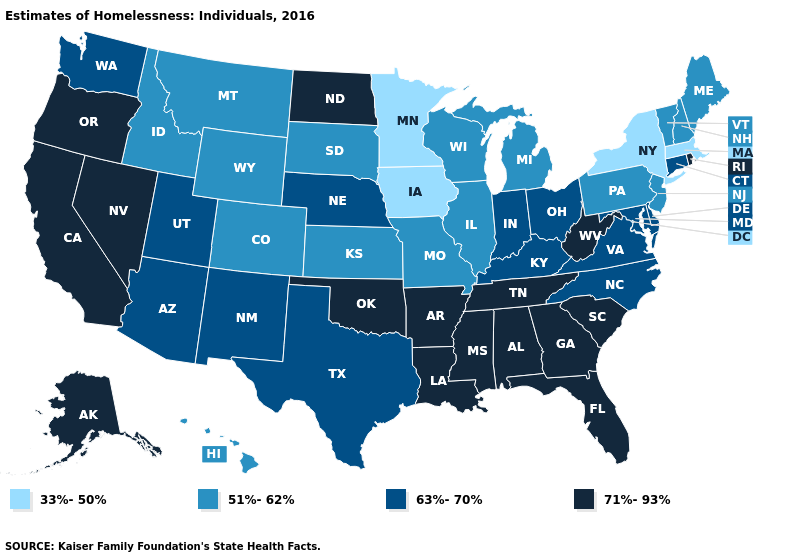Among the states that border Arizona , does Nevada have the highest value?
Give a very brief answer. Yes. Does Colorado have the lowest value in the West?
Answer briefly. Yes. Name the states that have a value in the range 33%-50%?
Be succinct. Iowa, Massachusetts, Minnesota, New York. Does Maine have the lowest value in the Northeast?
Quick response, please. No. What is the highest value in the USA?
Write a very short answer. 71%-93%. What is the lowest value in the Northeast?
Keep it brief. 33%-50%. Among the states that border North Dakota , which have the lowest value?
Short answer required. Minnesota. Name the states that have a value in the range 63%-70%?
Concise answer only. Arizona, Connecticut, Delaware, Indiana, Kentucky, Maryland, Nebraska, New Mexico, North Carolina, Ohio, Texas, Utah, Virginia, Washington. Name the states that have a value in the range 33%-50%?
Give a very brief answer. Iowa, Massachusetts, Minnesota, New York. Among the states that border Kentucky , does Missouri have the highest value?
Be succinct. No. How many symbols are there in the legend?
Concise answer only. 4. Name the states that have a value in the range 51%-62%?
Keep it brief. Colorado, Hawaii, Idaho, Illinois, Kansas, Maine, Michigan, Missouri, Montana, New Hampshire, New Jersey, Pennsylvania, South Dakota, Vermont, Wisconsin, Wyoming. Does Alabama have the same value as California?
Give a very brief answer. Yes. Name the states that have a value in the range 71%-93%?
Short answer required. Alabama, Alaska, Arkansas, California, Florida, Georgia, Louisiana, Mississippi, Nevada, North Dakota, Oklahoma, Oregon, Rhode Island, South Carolina, Tennessee, West Virginia. Does Indiana have the same value as Missouri?
Give a very brief answer. No. 